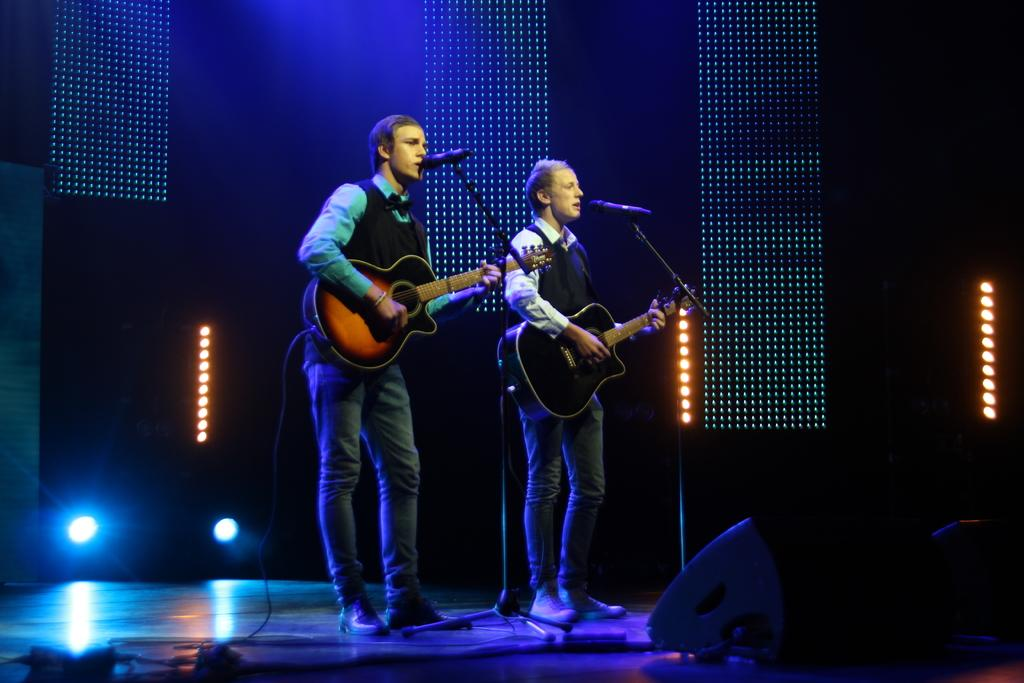How many people are in the image? There are two persons in the image. What are the two persons doing? One person is playing the guitar, and the other person is singing into a microphone. Can you describe the microphone setup in the image? There is a microphone behind the singers. What can be seen in the image that provides illumination? There is a light visible in the image. What type of flowers are being used as a nail polish remover in the image? There are no flowers or nail polish remover present in the image. 